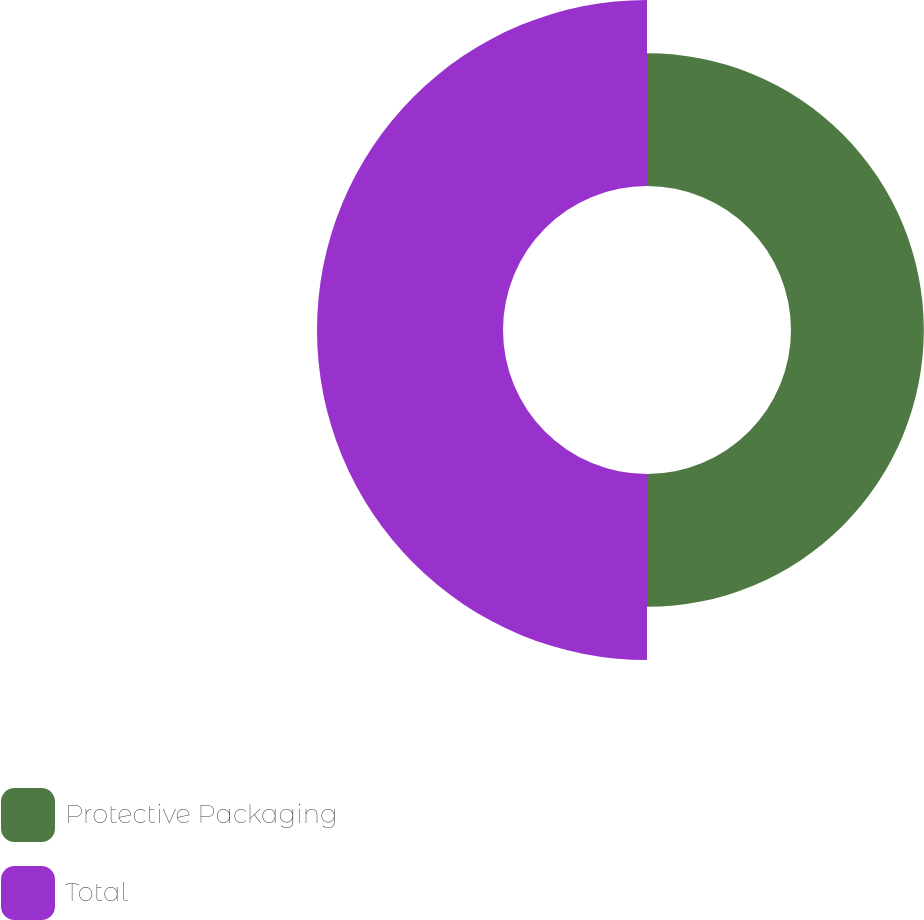Convert chart. <chart><loc_0><loc_0><loc_500><loc_500><pie_chart><fcel>Protective Packaging<fcel>Total<nl><fcel>41.66%<fcel>58.34%<nl></chart> 